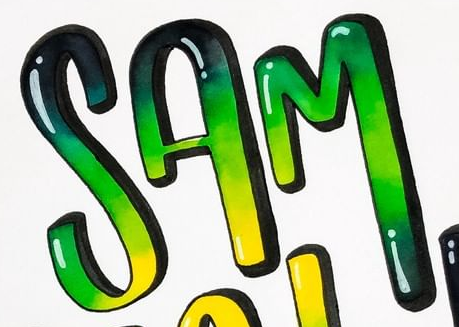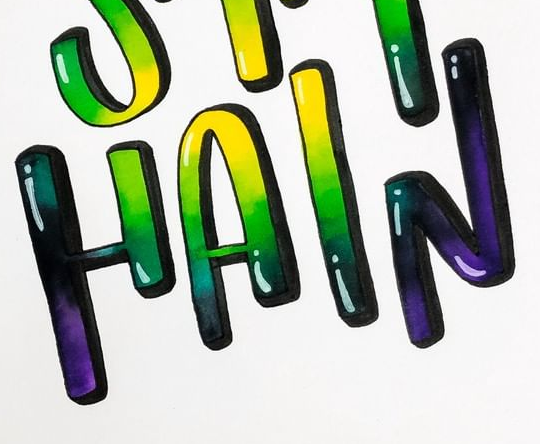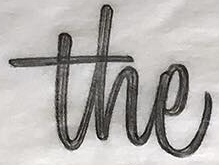Transcribe the words shown in these images in order, separated by a semicolon. SAM; HAIN; the 